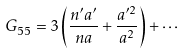Convert formula to latex. <formula><loc_0><loc_0><loc_500><loc_500>G _ { 5 5 } = 3 \left ( { \frac { n ^ { \prime } a ^ { \prime } } { n a } } + { \frac { a ^ { \prime 2 } } { a ^ { 2 } } } \right ) + \cdots</formula> 